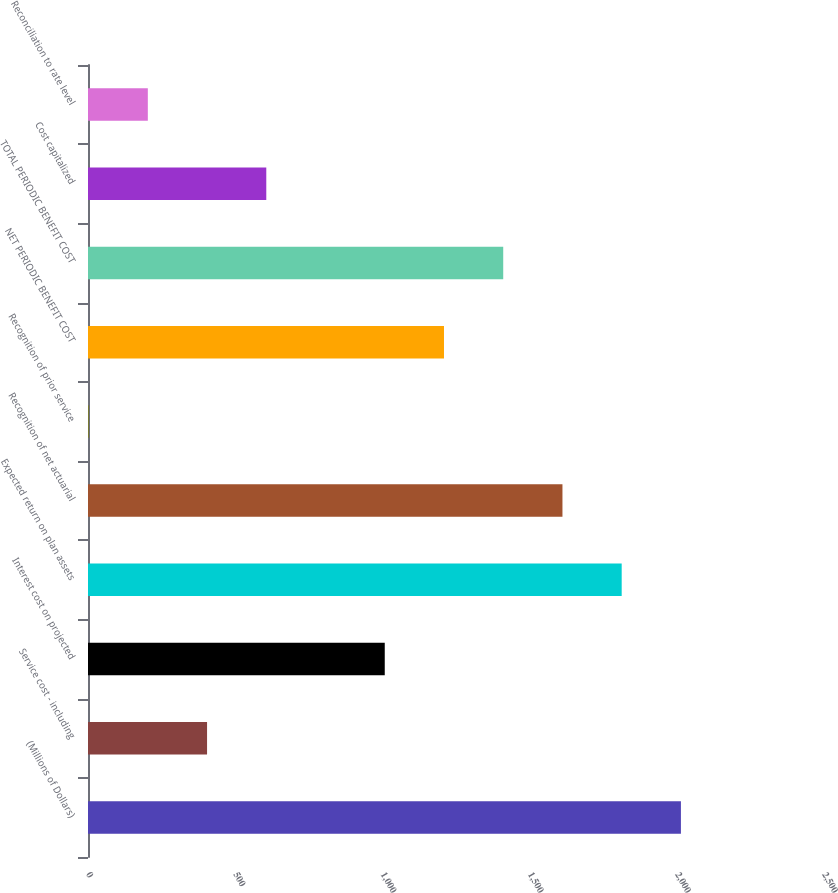<chart> <loc_0><loc_0><loc_500><loc_500><bar_chart><fcel>(Millions of Dollars)<fcel>Service cost - including<fcel>Interest cost on projected<fcel>Expected return on plan assets<fcel>Recognition of net actuarial<fcel>Recognition of prior service<fcel>NET PERIODIC BENEFIT COST<fcel>TOTAL PERIODIC BENEFIT COST<fcel>Cost capitalized<fcel>Reconciliation to rate level<nl><fcel>2014<fcel>404.4<fcel>1008<fcel>1812.8<fcel>1611.6<fcel>2<fcel>1209.2<fcel>1410.4<fcel>605.6<fcel>203.2<nl></chart> 